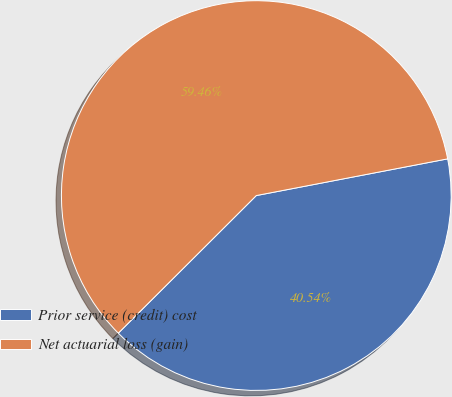Convert chart. <chart><loc_0><loc_0><loc_500><loc_500><pie_chart><fcel>Prior service (credit) cost<fcel>Net actuarial loss (gain)<nl><fcel>40.54%<fcel>59.46%<nl></chart> 